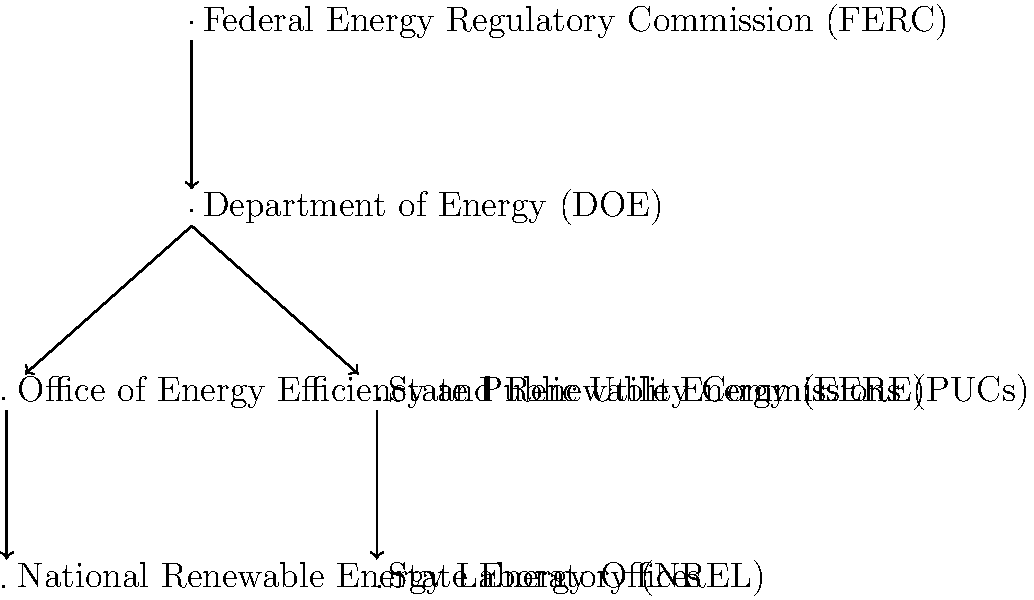In the hierarchical structure of regulatory bodies overseeing renewable energy sectors, which entity directly oversees both the Office of Energy Efficiency and Renewable Energy (EERE) and State Public Utility Commissions (PUCs)? To answer this question, let's analyze the hierarchical structure presented in the diagram:

1. At the top of the hierarchy is the Federal Energy Regulatory Commission (FERC).

2. Directly below FERC is the Department of Energy (DOE).

3. The DOE oversees two main branches:
   a) On the left: Office of Energy Efficiency and Renewable Energy (EERE)
   b) On the right: State Public Utility Commissions (PUCs)

4. Under the EERE, we see the National Renewable Energy Laboratory (NREL).

5. Under the PUCs, we see State Energy Offices.

6. The key observation is that both the EERE and PUCs are directly connected to the DOE in the hierarchy.

Therefore, the entity that directly oversees both the Office of Energy Efficiency and Renewable Energy (EERE) and State Public Utility Commissions (PUCs) is the Department of Energy (DOE).
Answer: Department of Energy (DOE) 